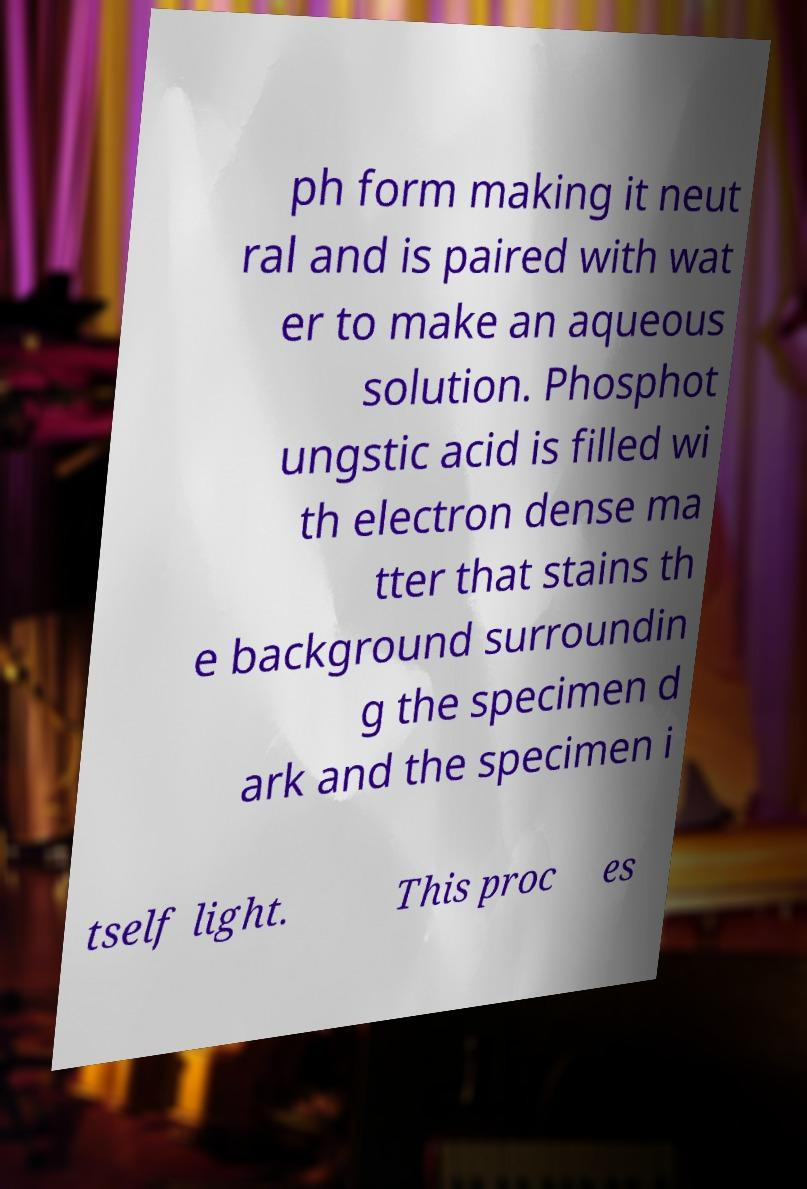Could you assist in decoding the text presented in this image and type it out clearly? ph form making it neut ral and is paired with wat er to make an aqueous solution. Phosphot ungstic acid is filled wi th electron dense ma tter that stains th e background surroundin g the specimen d ark and the specimen i tself light. This proc es 